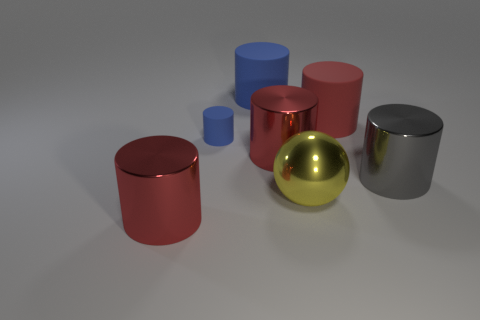Subtract all gray cubes. How many red cylinders are left? 3 Subtract all gray cylinders. How many cylinders are left? 5 Subtract all blue cylinders. How many cylinders are left? 4 Subtract 1 cylinders. How many cylinders are left? 5 Subtract all green cylinders. Subtract all yellow cubes. How many cylinders are left? 6 Add 3 metal objects. How many objects exist? 10 Subtract all cylinders. How many objects are left? 1 Subtract all large red shiny cylinders. Subtract all large gray shiny cylinders. How many objects are left? 4 Add 7 blue cylinders. How many blue cylinders are left? 9 Add 2 big cylinders. How many big cylinders exist? 7 